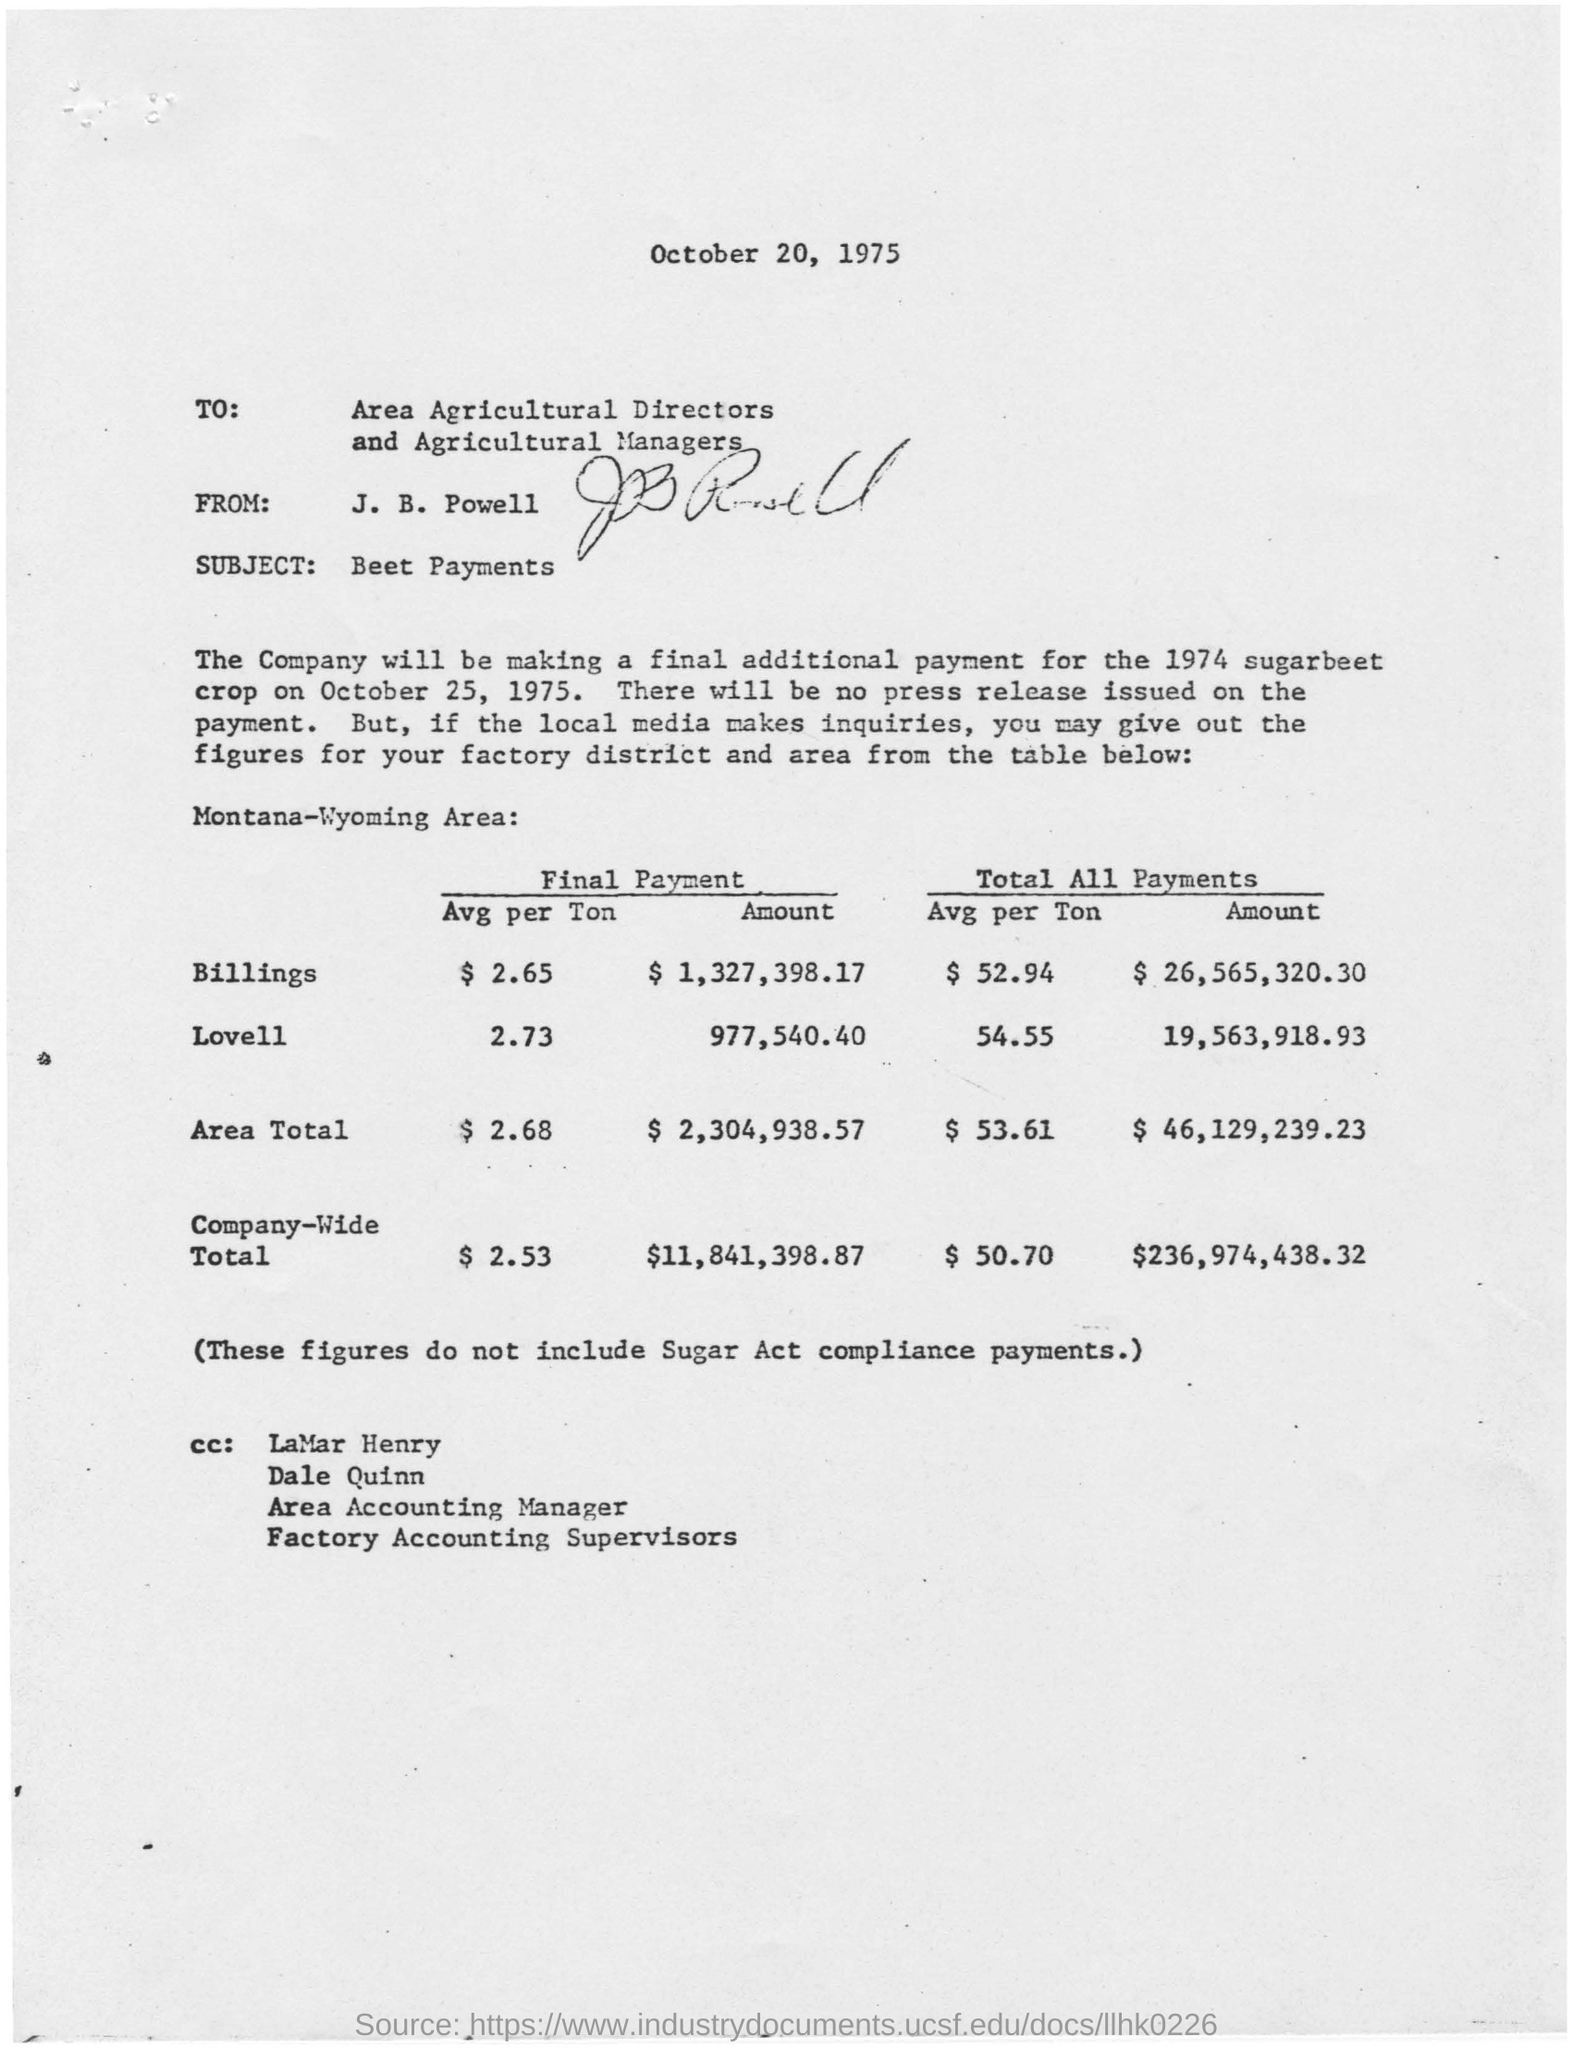What is the issued date of the letter?
Keep it short and to the point. October 20, 1975. To whom does the letter addressed to?
Ensure brevity in your answer.  Area Agricultural Directors and Agricultural Managers. Who is the sender of this letter?
Your answer should be very brief. J. B. Powell. What is the subject of this letter?
Make the answer very short. Beet Payments. What is the final payment amount for Company-wide total?
Offer a very short reply. $11,841,398.87. What is the final payment amount for Area Total?
Provide a succinct answer. $ 2,304,938.57. 